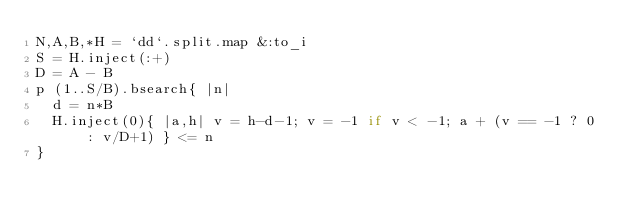<code> <loc_0><loc_0><loc_500><loc_500><_Ruby_>N,A,B,*H = `dd`.split.map &:to_i
S = H.inject(:+)
D = A - B
p (1..S/B).bsearch{ |n|
  d = n*B
  H.inject(0){ |a,h| v = h-d-1; v = -1 if v < -1; a + (v == -1 ? 0 : v/D+1) } <= n
}
</code> 